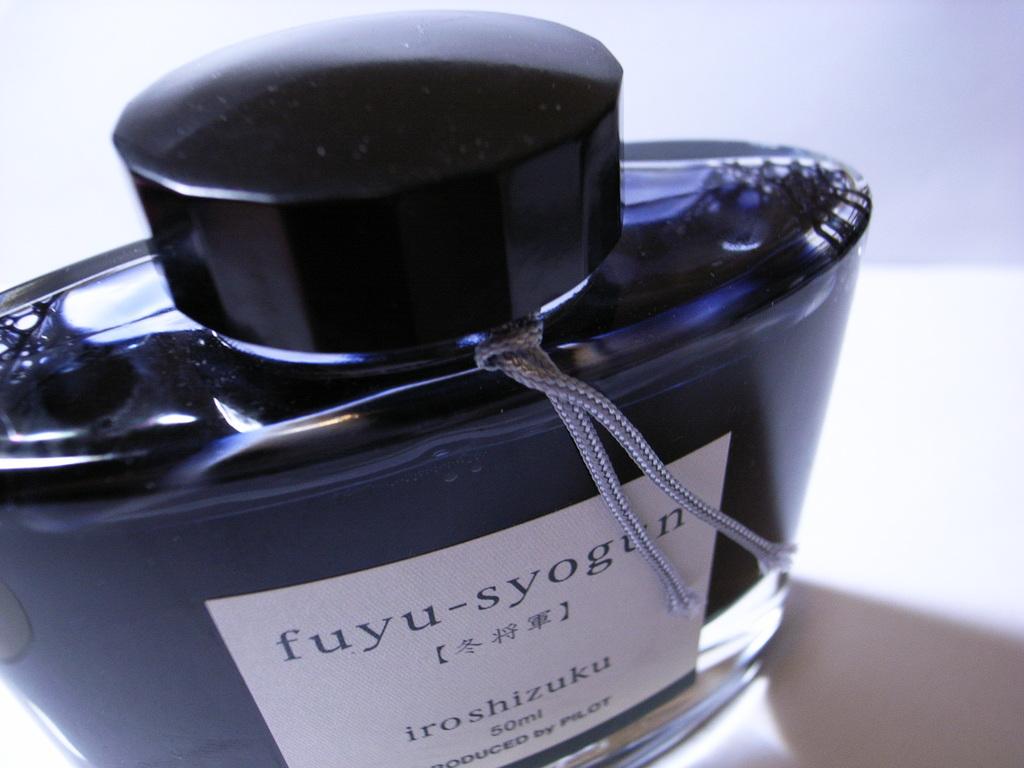How many milliliters are in this container?
Offer a very short reply. 50. /what brand is the bottle?
Keep it short and to the point. Fuyu-syogun. 